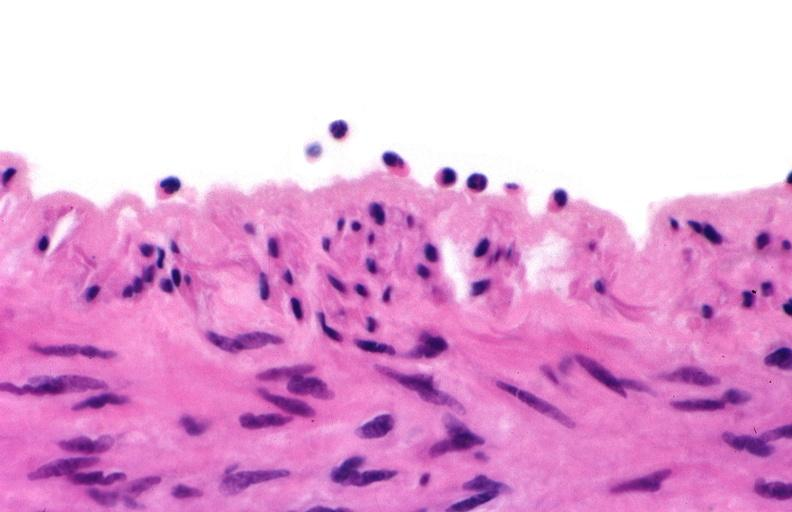what is present?
Answer the question using a single word or phrase. Cardiovascular 